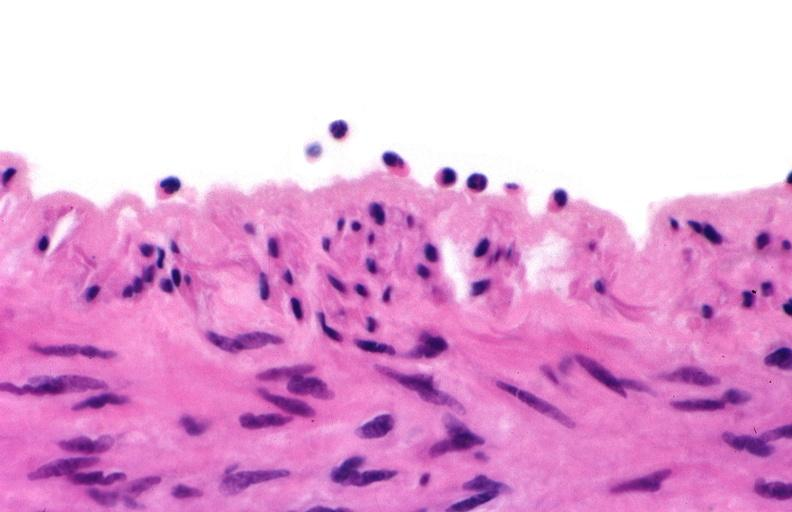what is present?
Answer the question using a single word or phrase. Cardiovascular 